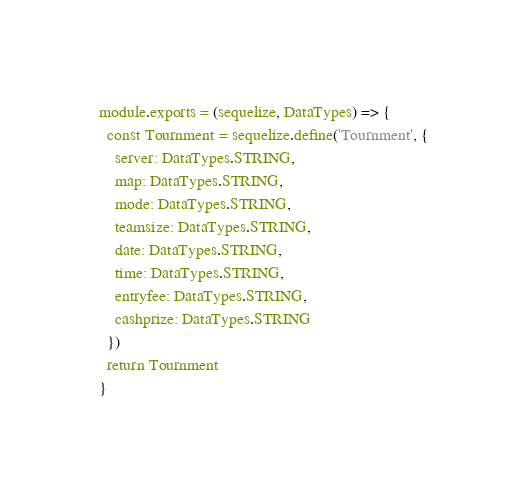Convert code to text. <code><loc_0><loc_0><loc_500><loc_500><_JavaScript_>module.exports = (sequelize, DataTypes) => {
  const Tournment = sequelize.define('Tournment', {
    server: DataTypes.STRING,
    map: DataTypes.STRING,
    mode: DataTypes.STRING,
    teamsize: DataTypes.STRING,
    date: DataTypes.STRING,
    time: DataTypes.STRING,
    entryfee: DataTypes.STRING,
    cashprize: DataTypes.STRING
  })
  return Tournment
}
</code> 